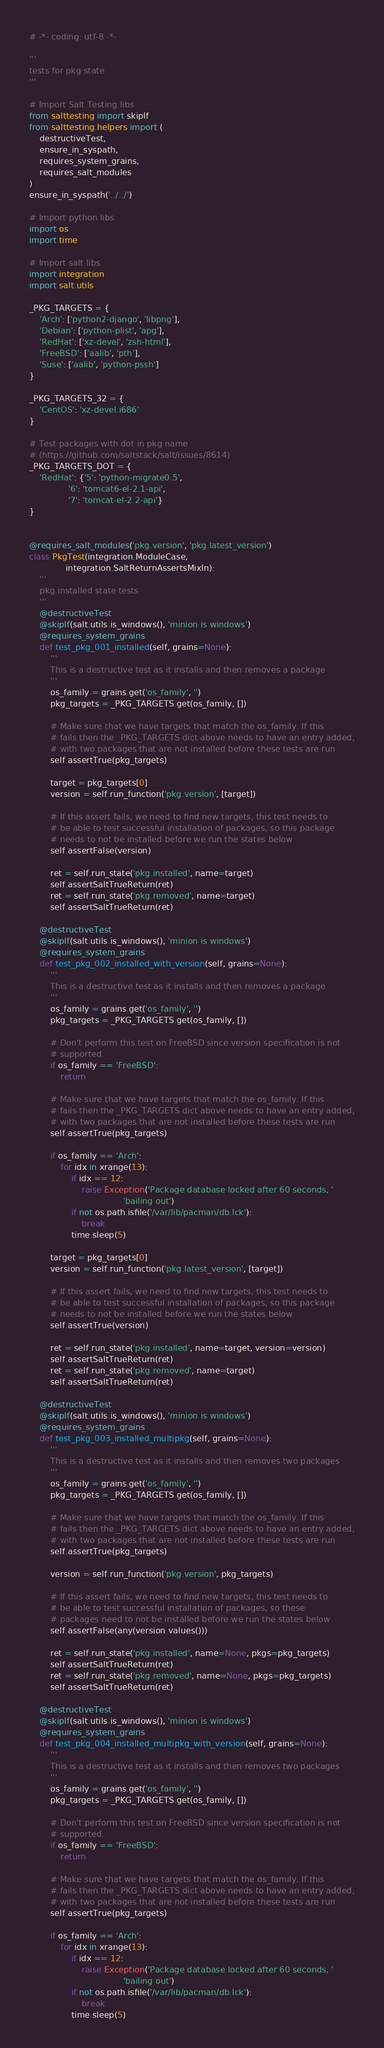<code> <loc_0><loc_0><loc_500><loc_500><_Python_># -*- coding: utf-8 -*-

'''
tests for pkg state
'''

# Import Salt Testing libs
from salttesting import skipIf
from salttesting.helpers import (
    destructiveTest,
    ensure_in_syspath,
    requires_system_grains,
    requires_salt_modules
)
ensure_in_syspath('../../')

# Import python libs
import os
import time

# Import salt libs
import integration
import salt.utils

_PKG_TARGETS = {
    'Arch': ['python2-django', 'libpng'],
    'Debian': ['python-plist', 'apg'],
    'RedHat': ['xz-devel', 'zsh-html'],
    'FreeBSD': ['aalib', 'pth'],
    'Suse': ['aalib', 'python-pssh']
}

_PKG_TARGETS_32 = {
    'CentOS': 'xz-devel.i686'
}

# Test packages with dot in pkg name
# (https://github.com/saltstack/salt/issues/8614)
_PKG_TARGETS_DOT = {
    'RedHat': {'5': 'python-migrate0.5',
               '6': 'tomcat6-el-2.1-api',
               '7': 'tomcat-el-2.2-api'}
}


@requires_salt_modules('pkg.version', 'pkg.latest_version')
class PkgTest(integration.ModuleCase,
              integration.SaltReturnAssertsMixIn):
    '''
    pkg.installed state tests
    '''
    @destructiveTest
    @skipIf(salt.utils.is_windows(), 'minion is windows')
    @requires_system_grains
    def test_pkg_001_installed(self, grains=None):
        '''
        This is a destructive test as it installs and then removes a package
        '''
        os_family = grains.get('os_family', '')
        pkg_targets = _PKG_TARGETS.get(os_family, [])

        # Make sure that we have targets that match the os_family. If this
        # fails then the _PKG_TARGETS dict above needs to have an entry added,
        # with two packages that are not installed before these tests are run
        self.assertTrue(pkg_targets)

        target = pkg_targets[0]
        version = self.run_function('pkg.version', [target])

        # If this assert fails, we need to find new targets, this test needs to
        # be able to test successful installation of packages, so this package
        # needs to not be installed before we run the states below
        self.assertFalse(version)

        ret = self.run_state('pkg.installed', name=target)
        self.assertSaltTrueReturn(ret)
        ret = self.run_state('pkg.removed', name=target)
        self.assertSaltTrueReturn(ret)

    @destructiveTest
    @skipIf(salt.utils.is_windows(), 'minion is windows')
    @requires_system_grains
    def test_pkg_002_installed_with_version(self, grains=None):
        '''
        This is a destructive test as it installs and then removes a package
        '''
        os_family = grains.get('os_family', '')
        pkg_targets = _PKG_TARGETS.get(os_family, [])

        # Don't perform this test on FreeBSD since version specification is not
        # supported.
        if os_family == 'FreeBSD':
            return

        # Make sure that we have targets that match the os_family. If this
        # fails then the _PKG_TARGETS dict above needs to have an entry added,
        # with two packages that are not installed before these tests are run
        self.assertTrue(pkg_targets)

        if os_family == 'Arch':
            for idx in xrange(13):
                if idx == 12:
                    raise Exception('Package database locked after 60 seconds, '
                                    'bailing out')
                if not os.path.isfile('/var/lib/pacman/db.lck'):
                    break
                time.sleep(5)

        target = pkg_targets[0]
        version = self.run_function('pkg.latest_version', [target])

        # If this assert fails, we need to find new targets, this test needs to
        # be able to test successful installation of packages, so this package
        # needs to not be installed before we run the states below
        self.assertTrue(version)

        ret = self.run_state('pkg.installed', name=target, version=version)
        self.assertSaltTrueReturn(ret)
        ret = self.run_state('pkg.removed', name=target)
        self.assertSaltTrueReturn(ret)

    @destructiveTest
    @skipIf(salt.utils.is_windows(), 'minion is windows')
    @requires_system_grains
    def test_pkg_003_installed_multipkg(self, grains=None):
        '''
        This is a destructive test as it installs and then removes two packages
        '''
        os_family = grains.get('os_family', '')
        pkg_targets = _PKG_TARGETS.get(os_family, [])

        # Make sure that we have targets that match the os_family. If this
        # fails then the _PKG_TARGETS dict above needs to have an entry added,
        # with two packages that are not installed before these tests are run
        self.assertTrue(pkg_targets)

        version = self.run_function('pkg.version', pkg_targets)

        # If this assert fails, we need to find new targets, this test needs to
        # be able to test successful installation of packages, so these
        # packages need to not be installed before we run the states below
        self.assertFalse(any(version.values()))

        ret = self.run_state('pkg.installed', name=None, pkgs=pkg_targets)
        self.assertSaltTrueReturn(ret)
        ret = self.run_state('pkg.removed', name=None, pkgs=pkg_targets)
        self.assertSaltTrueReturn(ret)

    @destructiveTest
    @skipIf(salt.utils.is_windows(), 'minion is windows')
    @requires_system_grains
    def test_pkg_004_installed_multipkg_with_version(self, grains=None):
        '''
        This is a destructive test as it installs and then removes two packages
        '''
        os_family = grains.get('os_family', '')
        pkg_targets = _PKG_TARGETS.get(os_family, [])

        # Don't perform this test on FreeBSD since version specification is not
        # supported.
        if os_family == 'FreeBSD':
            return

        # Make sure that we have targets that match the os_family. If this
        # fails then the _PKG_TARGETS dict above needs to have an entry added,
        # with two packages that are not installed before these tests are run
        self.assertTrue(pkg_targets)

        if os_family == 'Arch':
            for idx in xrange(13):
                if idx == 12:
                    raise Exception('Package database locked after 60 seconds, '
                                    'bailing out')
                if not os.path.isfile('/var/lib/pacman/db.lck'):
                    break
                time.sleep(5)
</code> 